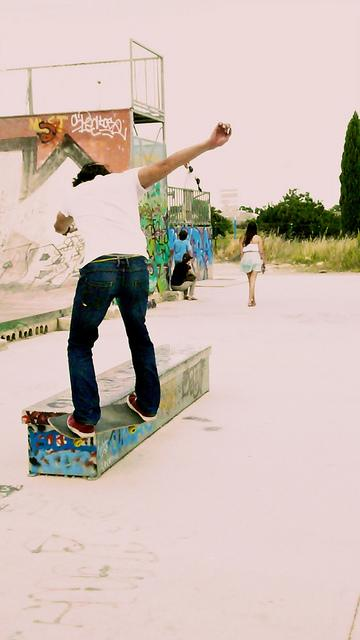Why si the board hanging from the box? jumping 